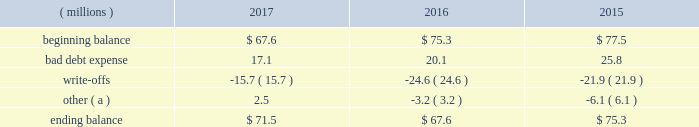Cash and cash equivalents cash equivalents include highly-liquid investments with a maturity of three months or less when purchased .
Accounts receivable and allowance for doubtful accounts accounts receivable are carried at the invoiced amounts , less an allowance for doubtful accounts , and generally do not bear interest .
The company estimates the balance of allowance for doubtful accounts by analyzing accounts receivable balances by age and applying historical write-off and collection trend rates .
The company 2019s estimates include separately providing for customer receivables based on specific circumstances and credit conditions , and when it is deemed probable that the balance is uncollectible .
Account balances are written off against the allowance when it is determined the receivable will not be recovered .
The company 2019s allowance for doubtful accounts balance also includes an allowance for the expected return of products shipped and credits related to pricing or quantities shipped of $ 15 million , $ 14 million and $ 15 million as of december 31 , 2017 , 2016 , and 2015 , respectively .
Returns and credit activity is recorded directly to sales as a reduction .
The table summarizes the activity in the allowance for doubtful accounts: .
( a ) other amounts are primarily the effects of changes in currency translations and the impact of allowance for returns and credits .
Inventory valuations inventories are valued at the lower of cost or net realizable value .
Certain u.s .
Inventory costs are determined on a last-in , first-out ( 201clifo 201d ) basis .
Lifo inventories represented 39% ( 39 % ) and 40% ( 40 % ) of consolidated inventories as of december 31 , 2017 and 2016 , respectively .
All other inventory costs are determined using either the average cost or first-in , first-out ( 201cfifo 201d ) methods .
Inventory values at fifo , as shown in note 5 , approximate replacement cost .
Property , plant and equipment property , plant and equipment assets are stated at cost .
Merchandising and customer equipment consists principally of various dispensing systems for the company 2019s cleaning and sanitizing products , dishwashing machines and process control and monitoring equipment .
Certain dispensing systems capitalized by the company are accounted for on a mass asset basis , whereby equipment is capitalized and depreciated as a group and written off when fully depreciated .
The company capitalizes both internal and external costs of development or purchase of computer software for internal use .
Costs incurred for data conversion , training and maintenance associated with capitalized software are expensed as incurred .
Expenditures for major renewals and improvements , which significantly extend the useful lives of existing plant and equipment , are capitalized and depreciated .
Expenditures for repairs and maintenance are charged to expense as incurred .
Upon retirement or disposition of plant and equipment , the cost and related accumulated depreciation are removed from the accounts and any resulting gain or loss is recognized in income .
Depreciation is charged to operations using the straight-line method over the assets 2019 estimated useful lives ranging from 5 to 40 years for buildings and leasehold improvements , 3 to 20 years for machinery and equipment , 3 to 15 years for merchandising and customer equipment and 3 to 7 years for capitalized software .
The straight-line method of depreciation reflects an appropriate allocation of the cost of the assets to earnings in proportion to the amount of economic benefits obtained by the company in each reporting period .
Depreciation expense was $ 586 million , $ 561 million and $ 560 million for 2017 , 2016 and 2015 , respectively. .
What is the percentage change in the balance of allowance for doubtful accounts from 2016 to 2017? 
Computations: ((71.5 - 67.6) / 67.6)
Answer: 0.05769. 